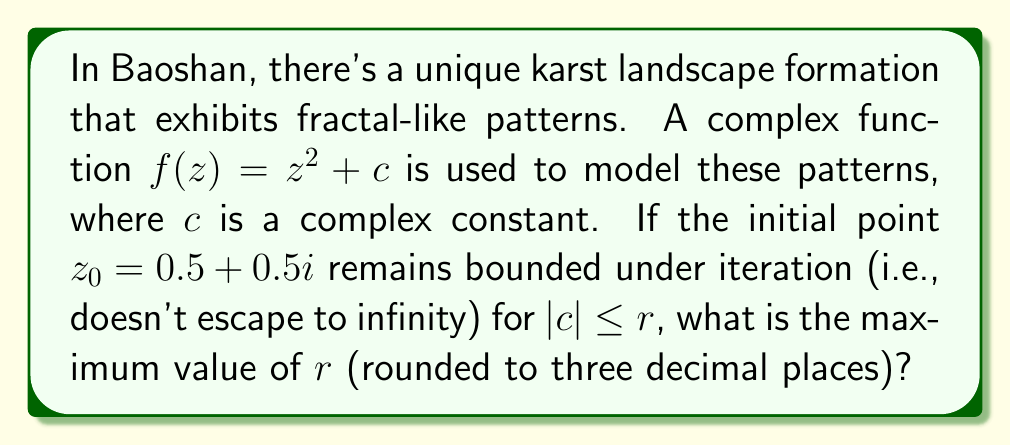Can you answer this question? To solve this problem, we need to understand the concept of the Mandelbrot set and its relationship to the given complex function.

1) The Mandelbrot set is defined as the set of complex numbers $c$ for which the function $f(z) = z^2 + c$ does not diverge when iterated from $z = 0$.

2) In this case, we're starting from $z_0 = 0.5 + 0.5i$ instead of $0$. This means we're looking at a point in the Julia set of $f(z)$ rather than the Mandelbrot set itself.

3) For a point to remain bounded, it must stay within the main cardioid of the Mandelbrot set or its period-2 bulb.

4) The boundary of the main cardioid is given by the equation:

   $$c = \frac{1}{4}e^{2\pi i \theta} - \frac{1}{4}e^{4\pi i \theta}$$

   where $\theta$ ranges from 0 to 1.

5) The maximum value of $|c|$ occurs at $\theta = 0$, which gives:

   $$c = \frac{1}{4} - \frac{1}{4} = 0$$

6) However, since we're starting from $z_0 = 0.5 + 0.5i$, we need to find the value of $c$ that maps this point to the origin:

   $$0.5 + 0.5i = (0.5 + 0.5i)^2 + c$$
   $$(0.25 - 0.25 + 0.5i) + c = 0.5 + 0.5i$$
   $$c = 0.5 + 0.5i - 0.5i = 0.5$$

7) Therefore, the maximum value of $|c|$ that keeps the orbit of $z_0 = 0.5 + 0.5i$ bounded is $r = 0.5$.
Answer: $0.500$ 